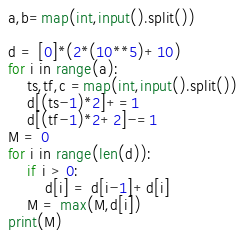<code> <loc_0><loc_0><loc_500><loc_500><_Python_>a,b=map(int,input().split())

d = [0]*(2*(10**5)+10)
for i in range(a):
    ts,tf,c =map(int,input().split())
    d[(ts-1)*2]+=1
    d[(tf-1)*2+2]-=1
M = 0
for i in range(len(d)):
    if i > 0:
        d[i] = d[i-1]+d[i]
    M = max(M,d[i])
print(M)
</code> 